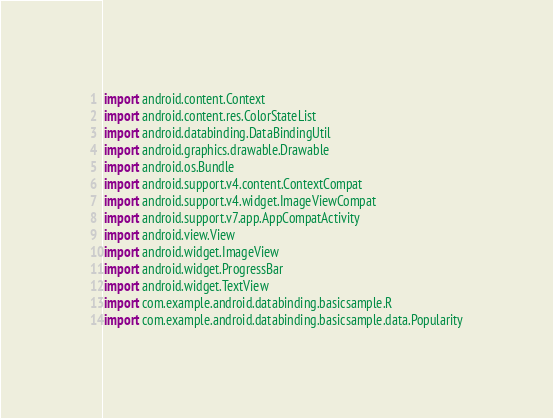Convert code to text. <code><loc_0><loc_0><loc_500><loc_500><_Kotlin_>import android.content.Context
import android.content.res.ColorStateList
import android.databinding.DataBindingUtil
import android.graphics.drawable.Drawable
import android.os.Bundle
import android.support.v4.content.ContextCompat
import android.support.v4.widget.ImageViewCompat
import android.support.v7.app.AppCompatActivity
import android.view.View
import android.widget.ImageView
import android.widget.ProgressBar
import android.widget.TextView
import com.example.android.databinding.basicsample.R
import com.example.android.databinding.basicsample.data.Popularity</code> 